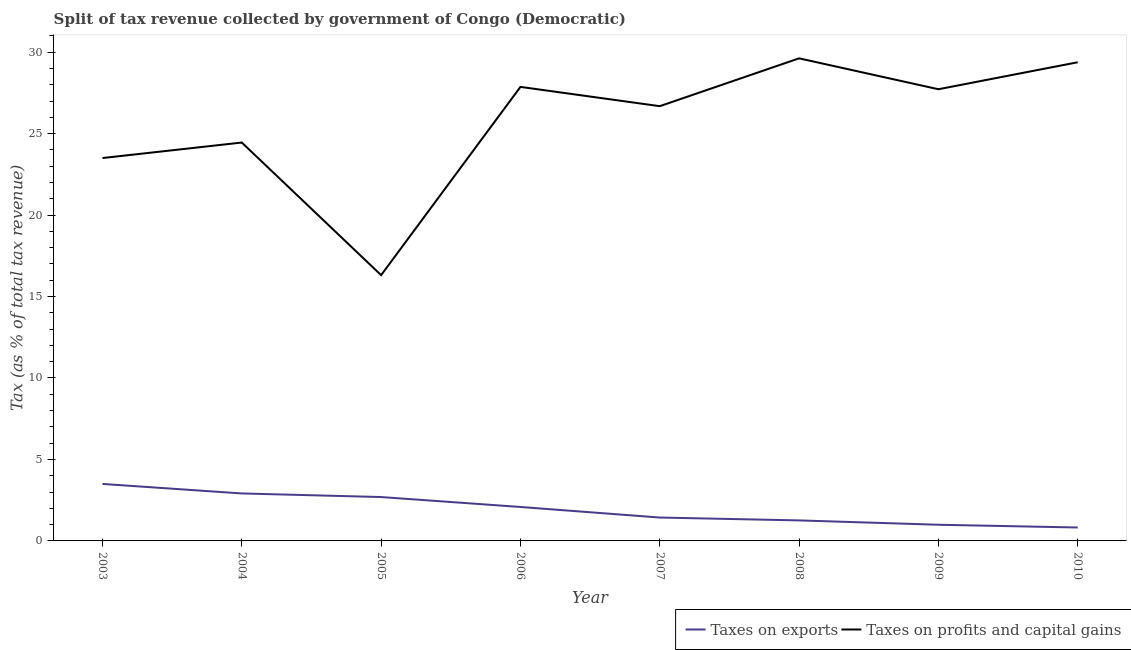Does the line corresponding to percentage of revenue obtained from taxes on profits and capital gains intersect with the line corresponding to percentage of revenue obtained from taxes on exports?
Offer a terse response. No. What is the percentage of revenue obtained from taxes on exports in 2004?
Provide a succinct answer. 2.91. Across all years, what is the maximum percentage of revenue obtained from taxes on exports?
Give a very brief answer. 3.5. Across all years, what is the minimum percentage of revenue obtained from taxes on exports?
Keep it short and to the point. 0.82. What is the total percentage of revenue obtained from taxes on profits and capital gains in the graph?
Provide a short and direct response. 205.54. What is the difference between the percentage of revenue obtained from taxes on profits and capital gains in 2003 and that in 2005?
Give a very brief answer. 7.19. What is the difference between the percentage of revenue obtained from taxes on profits and capital gains in 2008 and the percentage of revenue obtained from taxes on exports in 2007?
Your answer should be compact. 28.19. What is the average percentage of revenue obtained from taxes on profits and capital gains per year?
Offer a very short reply. 25.69. In the year 2005, what is the difference between the percentage of revenue obtained from taxes on exports and percentage of revenue obtained from taxes on profits and capital gains?
Your response must be concise. -13.62. What is the ratio of the percentage of revenue obtained from taxes on profits and capital gains in 2007 to that in 2009?
Ensure brevity in your answer.  0.96. Is the percentage of revenue obtained from taxes on exports in 2009 less than that in 2010?
Keep it short and to the point. No. What is the difference between the highest and the second highest percentage of revenue obtained from taxes on profits and capital gains?
Give a very brief answer. 0.24. What is the difference between the highest and the lowest percentage of revenue obtained from taxes on exports?
Offer a very short reply. 2.67. Is the sum of the percentage of revenue obtained from taxes on profits and capital gains in 2007 and 2008 greater than the maximum percentage of revenue obtained from taxes on exports across all years?
Make the answer very short. Yes. Does the graph contain grids?
Your answer should be compact. No. Where does the legend appear in the graph?
Ensure brevity in your answer.  Bottom right. How many legend labels are there?
Your response must be concise. 2. What is the title of the graph?
Provide a succinct answer. Split of tax revenue collected by government of Congo (Democratic). What is the label or title of the X-axis?
Provide a short and direct response. Year. What is the label or title of the Y-axis?
Make the answer very short. Tax (as % of total tax revenue). What is the Tax (as % of total tax revenue) in Taxes on exports in 2003?
Give a very brief answer. 3.5. What is the Tax (as % of total tax revenue) of Taxes on profits and capital gains in 2003?
Provide a short and direct response. 23.5. What is the Tax (as % of total tax revenue) in Taxes on exports in 2004?
Offer a terse response. 2.91. What is the Tax (as % of total tax revenue) of Taxes on profits and capital gains in 2004?
Your answer should be compact. 24.45. What is the Tax (as % of total tax revenue) of Taxes on exports in 2005?
Provide a succinct answer. 2.69. What is the Tax (as % of total tax revenue) of Taxes on profits and capital gains in 2005?
Your answer should be very brief. 16.31. What is the Tax (as % of total tax revenue) of Taxes on exports in 2006?
Keep it short and to the point. 2.08. What is the Tax (as % of total tax revenue) of Taxes on profits and capital gains in 2006?
Your answer should be compact. 27.87. What is the Tax (as % of total tax revenue) of Taxes on exports in 2007?
Your answer should be compact. 1.44. What is the Tax (as % of total tax revenue) of Taxes on profits and capital gains in 2007?
Offer a very short reply. 26.68. What is the Tax (as % of total tax revenue) of Taxes on exports in 2008?
Offer a very short reply. 1.26. What is the Tax (as % of total tax revenue) in Taxes on profits and capital gains in 2008?
Make the answer very short. 29.62. What is the Tax (as % of total tax revenue) of Taxes on exports in 2009?
Your response must be concise. 0.99. What is the Tax (as % of total tax revenue) in Taxes on profits and capital gains in 2009?
Give a very brief answer. 27.72. What is the Tax (as % of total tax revenue) of Taxes on exports in 2010?
Offer a very short reply. 0.82. What is the Tax (as % of total tax revenue) of Taxes on profits and capital gains in 2010?
Your answer should be compact. 29.38. Across all years, what is the maximum Tax (as % of total tax revenue) in Taxes on exports?
Give a very brief answer. 3.5. Across all years, what is the maximum Tax (as % of total tax revenue) in Taxes on profits and capital gains?
Offer a terse response. 29.62. Across all years, what is the minimum Tax (as % of total tax revenue) of Taxes on exports?
Give a very brief answer. 0.82. Across all years, what is the minimum Tax (as % of total tax revenue) of Taxes on profits and capital gains?
Your answer should be compact. 16.31. What is the total Tax (as % of total tax revenue) of Taxes on exports in the graph?
Keep it short and to the point. 15.7. What is the total Tax (as % of total tax revenue) of Taxes on profits and capital gains in the graph?
Give a very brief answer. 205.54. What is the difference between the Tax (as % of total tax revenue) in Taxes on exports in 2003 and that in 2004?
Make the answer very short. 0.58. What is the difference between the Tax (as % of total tax revenue) in Taxes on profits and capital gains in 2003 and that in 2004?
Offer a terse response. -0.95. What is the difference between the Tax (as % of total tax revenue) in Taxes on exports in 2003 and that in 2005?
Your response must be concise. 0.8. What is the difference between the Tax (as % of total tax revenue) in Taxes on profits and capital gains in 2003 and that in 2005?
Ensure brevity in your answer.  7.19. What is the difference between the Tax (as % of total tax revenue) in Taxes on exports in 2003 and that in 2006?
Provide a short and direct response. 1.41. What is the difference between the Tax (as % of total tax revenue) of Taxes on profits and capital gains in 2003 and that in 2006?
Give a very brief answer. -4.37. What is the difference between the Tax (as % of total tax revenue) in Taxes on exports in 2003 and that in 2007?
Make the answer very short. 2.06. What is the difference between the Tax (as % of total tax revenue) of Taxes on profits and capital gains in 2003 and that in 2007?
Provide a succinct answer. -3.18. What is the difference between the Tax (as % of total tax revenue) in Taxes on exports in 2003 and that in 2008?
Your answer should be very brief. 2.24. What is the difference between the Tax (as % of total tax revenue) of Taxes on profits and capital gains in 2003 and that in 2008?
Your answer should be compact. -6.12. What is the difference between the Tax (as % of total tax revenue) of Taxes on exports in 2003 and that in 2009?
Offer a terse response. 2.5. What is the difference between the Tax (as % of total tax revenue) of Taxes on profits and capital gains in 2003 and that in 2009?
Provide a short and direct response. -4.22. What is the difference between the Tax (as % of total tax revenue) in Taxes on exports in 2003 and that in 2010?
Keep it short and to the point. 2.67. What is the difference between the Tax (as % of total tax revenue) in Taxes on profits and capital gains in 2003 and that in 2010?
Give a very brief answer. -5.88. What is the difference between the Tax (as % of total tax revenue) in Taxes on exports in 2004 and that in 2005?
Give a very brief answer. 0.22. What is the difference between the Tax (as % of total tax revenue) in Taxes on profits and capital gains in 2004 and that in 2005?
Make the answer very short. 8.14. What is the difference between the Tax (as % of total tax revenue) of Taxes on exports in 2004 and that in 2006?
Your answer should be very brief. 0.83. What is the difference between the Tax (as % of total tax revenue) in Taxes on profits and capital gains in 2004 and that in 2006?
Your response must be concise. -3.42. What is the difference between the Tax (as % of total tax revenue) in Taxes on exports in 2004 and that in 2007?
Offer a terse response. 1.48. What is the difference between the Tax (as % of total tax revenue) in Taxes on profits and capital gains in 2004 and that in 2007?
Ensure brevity in your answer.  -2.23. What is the difference between the Tax (as % of total tax revenue) in Taxes on exports in 2004 and that in 2008?
Ensure brevity in your answer.  1.65. What is the difference between the Tax (as % of total tax revenue) of Taxes on profits and capital gains in 2004 and that in 2008?
Your answer should be very brief. -5.17. What is the difference between the Tax (as % of total tax revenue) of Taxes on exports in 2004 and that in 2009?
Ensure brevity in your answer.  1.92. What is the difference between the Tax (as % of total tax revenue) in Taxes on profits and capital gains in 2004 and that in 2009?
Provide a succinct answer. -3.27. What is the difference between the Tax (as % of total tax revenue) in Taxes on exports in 2004 and that in 2010?
Keep it short and to the point. 2.09. What is the difference between the Tax (as % of total tax revenue) of Taxes on profits and capital gains in 2004 and that in 2010?
Give a very brief answer. -4.93. What is the difference between the Tax (as % of total tax revenue) of Taxes on exports in 2005 and that in 2006?
Give a very brief answer. 0.61. What is the difference between the Tax (as % of total tax revenue) of Taxes on profits and capital gains in 2005 and that in 2006?
Ensure brevity in your answer.  -11.55. What is the difference between the Tax (as % of total tax revenue) of Taxes on exports in 2005 and that in 2007?
Provide a short and direct response. 1.26. What is the difference between the Tax (as % of total tax revenue) in Taxes on profits and capital gains in 2005 and that in 2007?
Ensure brevity in your answer.  -10.37. What is the difference between the Tax (as % of total tax revenue) in Taxes on exports in 2005 and that in 2008?
Offer a terse response. 1.43. What is the difference between the Tax (as % of total tax revenue) of Taxes on profits and capital gains in 2005 and that in 2008?
Offer a very short reply. -13.31. What is the difference between the Tax (as % of total tax revenue) in Taxes on exports in 2005 and that in 2009?
Your response must be concise. 1.7. What is the difference between the Tax (as % of total tax revenue) of Taxes on profits and capital gains in 2005 and that in 2009?
Offer a terse response. -11.41. What is the difference between the Tax (as % of total tax revenue) of Taxes on exports in 2005 and that in 2010?
Your answer should be very brief. 1.87. What is the difference between the Tax (as % of total tax revenue) of Taxes on profits and capital gains in 2005 and that in 2010?
Your answer should be very brief. -13.07. What is the difference between the Tax (as % of total tax revenue) of Taxes on exports in 2006 and that in 2007?
Make the answer very short. 0.65. What is the difference between the Tax (as % of total tax revenue) of Taxes on profits and capital gains in 2006 and that in 2007?
Keep it short and to the point. 1.18. What is the difference between the Tax (as % of total tax revenue) of Taxes on exports in 2006 and that in 2008?
Ensure brevity in your answer.  0.82. What is the difference between the Tax (as % of total tax revenue) of Taxes on profits and capital gains in 2006 and that in 2008?
Offer a very short reply. -1.75. What is the difference between the Tax (as % of total tax revenue) of Taxes on exports in 2006 and that in 2009?
Ensure brevity in your answer.  1.09. What is the difference between the Tax (as % of total tax revenue) of Taxes on profits and capital gains in 2006 and that in 2009?
Provide a succinct answer. 0.14. What is the difference between the Tax (as % of total tax revenue) of Taxes on exports in 2006 and that in 2010?
Offer a terse response. 1.26. What is the difference between the Tax (as % of total tax revenue) of Taxes on profits and capital gains in 2006 and that in 2010?
Your answer should be very brief. -1.51. What is the difference between the Tax (as % of total tax revenue) of Taxes on exports in 2007 and that in 2008?
Your answer should be very brief. 0.18. What is the difference between the Tax (as % of total tax revenue) of Taxes on profits and capital gains in 2007 and that in 2008?
Offer a very short reply. -2.94. What is the difference between the Tax (as % of total tax revenue) in Taxes on exports in 2007 and that in 2009?
Your answer should be very brief. 0.44. What is the difference between the Tax (as % of total tax revenue) of Taxes on profits and capital gains in 2007 and that in 2009?
Ensure brevity in your answer.  -1.04. What is the difference between the Tax (as % of total tax revenue) of Taxes on exports in 2007 and that in 2010?
Offer a very short reply. 0.61. What is the difference between the Tax (as % of total tax revenue) in Taxes on profits and capital gains in 2007 and that in 2010?
Provide a short and direct response. -2.7. What is the difference between the Tax (as % of total tax revenue) in Taxes on exports in 2008 and that in 2009?
Your answer should be compact. 0.27. What is the difference between the Tax (as % of total tax revenue) in Taxes on profits and capital gains in 2008 and that in 2009?
Your answer should be compact. 1.9. What is the difference between the Tax (as % of total tax revenue) in Taxes on exports in 2008 and that in 2010?
Your response must be concise. 0.44. What is the difference between the Tax (as % of total tax revenue) in Taxes on profits and capital gains in 2008 and that in 2010?
Give a very brief answer. 0.24. What is the difference between the Tax (as % of total tax revenue) of Taxes on exports in 2009 and that in 2010?
Keep it short and to the point. 0.17. What is the difference between the Tax (as % of total tax revenue) of Taxes on profits and capital gains in 2009 and that in 2010?
Give a very brief answer. -1.66. What is the difference between the Tax (as % of total tax revenue) in Taxes on exports in 2003 and the Tax (as % of total tax revenue) in Taxes on profits and capital gains in 2004?
Ensure brevity in your answer.  -20.95. What is the difference between the Tax (as % of total tax revenue) of Taxes on exports in 2003 and the Tax (as % of total tax revenue) of Taxes on profits and capital gains in 2005?
Offer a terse response. -12.82. What is the difference between the Tax (as % of total tax revenue) in Taxes on exports in 2003 and the Tax (as % of total tax revenue) in Taxes on profits and capital gains in 2006?
Give a very brief answer. -24.37. What is the difference between the Tax (as % of total tax revenue) in Taxes on exports in 2003 and the Tax (as % of total tax revenue) in Taxes on profits and capital gains in 2007?
Your answer should be compact. -23.19. What is the difference between the Tax (as % of total tax revenue) in Taxes on exports in 2003 and the Tax (as % of total tax revenue) in Taxes on profits and capital gains in 2008?
Offer a terse response. -26.12. What is the difference between the Tax (as % of total tax revenue) in Taxes on exports in 2003 and the Tax (as % of total tax revenue) in Taxes on profits and capital gains in 2009?
Keep it short and to the point. -24.23. What is the difference between the Tax (as % of total tax revenue) in Taxes on exports in 2003 and the Tax (as % of total tax revenue) in Taxes on profits and capital gains in 2010?
Provide a short and direct response. -25.88. What is the difference between the Tax (as % of total tax revenue) in Taxes on exports in 2004 and the Tax (as % of total tax revenue) in Taxes on profits and capital gains in 2005?
Your answer should be compact. -13.4. What is the difference between the Tax (as % of total tax revenue) in Taxes on exports in 2004 and the Tax (as % of total tax revenue) in Taxes on profits and capital gains in 2006?
Give a very brief answer. -24.95. What is the difference between the Tax (as % of total tax revenue) of Taxes on exports in 2004 and the Tax (as % of total tax revenue) of Taxes on profits and capital gains in 2007?
Keep it short and to the point. -23.77. What is the difference between the Tax (as % of total tax revenue) of Taxes on exports in 2004 and the Tax (as % of total tax revenue) of Taxes on profits and capital gains in 2008?
Provide a succinct answer. -26.71. What is the difference between the Tax (as % of total tax revenue) in Taxes on exports in 2004 and the Tax (as % of total tax revenue) in Taxes on profits and capital gains in 2009?
Provide a succinct answer. -24.81. What is the difference between the Tax (as % of total tax revenue) in Taxes on exports in 2004 and the Tax (as % of total tax revenue) in Taxes on profits and capital gains in 2010?
Offer a terse response. -26.47. What is the difference between the Tax (as % of total tax revenue) in Taxes on exports in 2005 and the Tax (as % of total tax revenue) in Taxes on profits and capital gains in 2006?
Your response must be concise. -25.17. What is the difference between the Tax (as % of total tax revenue) in Taxes on exports in 2005 and the Tax (as % of total tax revenue) in Taxes on profits and capital gains in 2007?
Your response must be concise. -23.99. What is the difference between the Tax (as % of total tax revenue) in Taxes on exports in 2005 and the Tax (as % of total tax revenue) in Taxes on profits and capital gains in 2008?
Your response must be concise. -26.93. What is the difference between the Tax (as % of total tax revenue) in Taxes on exports in 2005 and the Tax (as % of total tax revenue) in Taxes on profits and capital gains in 2009?
Your response must be concise. -25.03. What is the difference between the Tax (as % of total tax revenue) of Taxes on exports in 2005 and the Tax (as % of total tax revenue) of Taxes on profits and capital gains in 2010?
Provide a succinct answer. -26.69. What is the difference between the Tax (as % of total tax revenue) in Taxes on exports in 2006 and the Tax (as % of total tax revenue) in Taxes on profits and capital gains in 2007?
Your answer should be compact. -24.6. What is the difference between the Tax (as % of total tax revenue) in Taxes on exports in 2006 and the Tax (as % of total tax revenue) in Taxes on profits and capital gains in 2008?
Keep it short and to the point. -27.54. What is the difference between the Tax (as % of total tax revenue) in Taxes on exports in 2006 and the Tax (as % of total tax revenue) in Taxes on profits and capital gains in 2009?
Give a very brief answer. -25.64. What is the difference between the Tax (as % of total tax revenue) of Taxes on exports in 2006 and the Tax (as % of total tax revenue) of Taxes on profits and capital gains in 2010?
Your answer should be compact. -27.3. What is the difference between the Tax (as % of total tax revenue) in Taxes on exports in 2007 and the Tax (as % of total tax revenue) in Taxes on profits and capital gains in 2008?
Your answer should be compact. -28.19. What is the difference between the Tax (as % of total tax revenue) in Taxes on exports in 2007 and the Tax (as % of total tax revenue) in Taxes on profits and capital gains in 2009?
Offer a very short reply. -26.29. What is the difference between the Tax (as % of total tax revenue) in Taxes on exports in 2007 and the Tax (as % of total tax revenue) in Taxes on profits and capital gains in 2010?
Keep it short and to the point. -27.94. What is the difference between the Tax (as % of total tax revenue) of Taxes on exports in 2008 and the Tax (as % of total tax revenue) of Taxes on profits and capital gains in 2009?
Provide a succinct answer. -26.46. What is the difference between the Tax (as % of total tax revenue) in Taxes on exports in 2008 and the Tax (as % of total tax revenue) in Taxes on profits and capital gains in 2010?
Your response must be concise. -28.12. What is the difference between the Tax (as % of total tax revenue) in Taxes on exports in 2009 and the Tax (as % of total tax revenue) in Taxes on profits and capital gains in 2010?
Provide a succinct answer. -28.39. What is the average Tax (as % of total tax revenue) of Taxes on exports per year?
Give a very brief answer. 1.96. What is the average Tax (as % of total tax revenue) in Taxes on profits and capital gains per year?
Offer a very short reply. 25.69. In the year 2003, what is the difference between the Tax (as % of total tax revenue) of Taxes on exports and Tax (as % of total tax revenue) of Taxes on profits and capital gains?
Ensure brevity in your answer.  -20. In the year 2004, what is the difference between the Tax (as % of total tax revenue) in Taxes on exports and Tax (as % of total tax revenue) in Taxes on profits and capital gains?
Keep it short and to the point. -21.54. In the year 2005, what is the difference between the Tax (as % of total tax revenue) of Taxes on exports and Tax (as % of total tax revenue) of Taxes on profits and capital gains?
Make the answer very short. -13.62. In the year 2006, what is the difference between the Tax (as % of total tax revenue) in Taxes on exports and Tax (as % of total tax revenue) in Taxes on profits and capital gains?
Give a very brief answer. -25.78. In the year 2007, what is the difference between the Tax (as % of total tax revenue) of Taxes on exports and Tax (as % of total tax revenue) of Taxes on profits and capital gains?
Your answer should be compact. -25.25. In the year 2008, what is the difference between the Tax (as % of total tax revenue) of Taxes on exports and Tax (as % of total tax revenue) of Taxes on profits and capital gains?
Offer a terse response. -28.36. In the year 2009, what is the difference between the Tax (as % of total tax revenue) of Taxes on exports and Tax (as % of total tax revenue) of Taxes on profits and capital gains?
Give a very brief answer. -26.73. In the year 2010, what is the difference between the Tax (as % of total tax revenue) of Taxes on exports and Tax (as % of total tax revenue) of Taxes on profits and capital gains?
Offer a very short reply. -28.56. What is the ratio of the Tax (as % of total tax revenue) of Taxes on exports in 2003 to that in 2004?
Provide a short and direct response. 1.2. What is the ratio of the Tax (as % of total tax revenue) of Taxes on profits and capital gains in 2003 to that in 2004?
Your answer should be very brief. 0.96. What is the ratio of the Tax (as % of total tax revenue) of Taxes on exports in 2003 to that in 2005?
Ensure brevity in your answer.  1.3. What is the ratio of the Tax (as % of total tax revenue) in Taxes on profits and capital gains in 2003 to that in 2005?
Your response must be concise. 1.44. What is the ratio of the Tax (as % of total tax revenue) in Taxes on exports in 2003 to that in 2006?
Your answer should be compact. 1.68. What is the ratio of the Tax (as % of total tax revenue) of Taxes on profits and capital gains in 2003 to that in 2006?
Keep it short and to the point. 0.84. What is the ratio of the Tax (as % of total tax revenue) of Taxes on exports in 2003 to that in 2007?
Ensure brevity in your answer.  2.44. What is the ratio of the Tax (as % of total tax revenue) of Taxes on profits and capital gains in 2003 to that in 2007?
Give a very brief answer. 0.88. What is the ratio of the Tax (as % of total tax revenue) in Taxes on exports in 2003 to that in 2008?
Offer a terse response. 2.78. What is the ratio of the Tax (as % of total tax revenue) in Taxes on profits and capital gains in 2003 to that in 2008?
Your answer should be very brief. 0.79. What is the ratio of the Tax (as % of total tax revenue) in Taxes on exports in 2003 to that in 2009?
Keep it short and to the point. 3.52. What is the ratio of the Tax (as % of total tax revenue) in Taxes on profits and capital gains in 2003 to that in 2009?
Keep it short and to the point. 0.85. What is the ratio of the Tax (as % of total tax revenue) of Taxes on exports in 2003 to that in 2010?
Your answer should be compact. 4.25. What is the ratio of the Tax (as % of total tax revenue) of Taxes on profits and capital gains in 2003 to that in 2010?
Make the answer very short. 0.8. What is the ratio of the Tax (as % of total tax revenue) in Taxes on exports in 2004 to that in 2005?
Offer a very short reply. 1.08. What is the ratio of the Tax (as % of total tax revenue) in Taxes on profits and capital gains in 2004 to that in 2005?
Your answer should be very brief. 1.5. What is the ratio of the Tax (as % of total tax revenue) of Taxes on exports in 2004 to that in 2006?
Ensure brevity in your answer.  1.4. What is the ratio of the Tax (as % of total tax revenue) in Taxes on profits and capital gains in 2004 to that in 2006?
Provide a short and direct response. 0.88. What is the ratio of the Tax (as % of total tax revenue) in Taxes on exports in 2004 to that in 2007?
Your answer should be very brief. 2.03. What is the ratio of the Tax (as % of total tax revenue) in Taxes on profits and capital gains in 2004 to that in 2007?
Offer a very short reply. 0.92. What is the ratio of the Tax (as % of total tax revenue) of Taxes on exports in 2004 to that in 2008?
Ensure brevity in your answer.  2.31. What is the ratio of the Tax (as % of total tax revenue) of Taxes on profits and capital gains in 2004 to that in 2008?
Give a very brief answer. 0.83. What is the ratio of the Tax (as % of total tax revenue) of Taxes on exports in 2004 to that in 2009?
Keep it short and to the point. 2.94. What is the ratio of the Tax (as % of total tax revenue) of Taxes on profits and capital gains in 2004 to that in 2009?
Your answer should be compact. 0.88. What is the ratio of the Tax (as % of total tax revenue) in Taxes on exports in 2004 to that in 2010?
Keep it short and to the point. 3.54. What is the ratio of the Tax (as % of total tax revenue) in Taxes on profits and capital gains in 2004 to that in 2010?
Your answer should be very brief. 0.83. What is the ratio of the Tax (as % of total tax revenue) in Taxes on exports in 2005 to that in 2006?
Keep it short and to the point. 1.29. What is the ratio of the Tax (as % of total tax revenue) of Taxes on profits and capital gains in 2005 to that in 2006?
Give a very brief answer. 0.59. What is the ratio of the Tax (as % of total tax revenue) of Taxes on exports in 2005 to that in 2007?
Your answer should be compact. 1.88. What is the ratio of the Tax (as % of total tax revenue) in Taxes on profits and capital gains in 2005 to that in 2007?
Offer a very short reply. 0.61. What is the ratio of the Tax (as % of total tax revenue) in Taxes on exports in 2005 to that in 2008?
Give a very brief answer. 2.14. What is the ratio of the Tax (as % of total tax revenue) in Taxes on profits and capital gains in 2005 to that in 2008?
Give a very brief answer. 0.55. What is the ratio of the Tax (as % of total tax revenue) of Taxes on exports in 2005 to that in 2009?
Provide a short and direct response. 2.71. What is the ratio of the Tax (as % of total tax revenue) in Taxes on profits and capital gains in 2005 to that in 2009?
Your response must be concise. 0.59. What is the ratio of the Tax (as % of total tax revenue) of Taxes on exports in 2005 to that in 2010?
Provide a short and direct response. 3.27. What is the ratio of the Tax (as % of total tax revenue) in Taxes on profits and capital gains in 2005 to that in 2010?
Offer a terse response. 0.56. What is the ratio of the Tax (as % of total tax revenue) in Taxes on exports in 2006 to that in 2007?
Provide a succinct answer. 1.45. What is the ratio of the Tax (as % of total tax revenue) in Taxes on profits and capital gains in 2006 to that in 2007?
Provide a short and direct response. 1.04. What is the ratio of the Tax (as % of total tax revenue) in Taxes on exports in 2006 to that in 2008?
Provide a short and direct response. 1.66. What is the ratio of the Tax (as % of total tax revenue) of Taxes on profits and capital gains in 2006 to that in 2008?
Your response must be concise. 0.94. What is the ratio of the Tax (as % of total tax revenue) of Taxes on exports in 2006 to that in 2009?
Make the answer very short. 2.1. What is the ratio of the Tax (as % of total tax revenue) in Taxes on profits and capital gains in 2006 to that in 2009?
Ensure brevity in your answer.  1.01. What is the ratio of the Tax (as % of total tax revenue) of Taxes on exports in 2006 to that in 2010?
Your answer should be compact. 2.53. What is the ratio of the Tax (as % of total tax revenue) of Taxes on profits and capital gains in 2006 to that in 2010?
Provide a succinct answer. 0.95. What is the ratio of the Tax (as % of total tax revenue) of Taxes on exports in 2007 to that in 2008?
Ensure brevity in your answer.  1.14. What is the ratio of the Tax (as % of total tax revenue) in Taxes on profits and capital gains in 2007 to that in 2008?
Offer a very short reply. 0.9. What is the ratio of the Tax (as % of total tax revenue) of Taxes on exports in 2007 to that in 2009?
Make the answer very short. 1.45. What is the ratio of the Tax (as % of total tax revenue) in Taxes on profits and capital gains in 2007 to that in 2009?
Make the answer very short. 0.96. What is the ratio of the Tax (as % of total tax revenue) in Taxes on exports in 2007 to that in 2010?
Keep it short and to the point. 1.74. What is the ratio of the Tax (as % of total tax revenue) of Taxes on profits and capital gains in 2007 to that in 2010?
Provide a succinct answer. 0.91. What is the ratio of the Tax (as % of total tax revenue) in Taxes on exports in 2008 to that in 2009?
Make the answer very short. 1.27. What is the ratio of the Tax (as % of total tax revenue) in Taxes on profits and capital gains in 2008 to that in 2009?
Offer a very short reply. 1.07. What is the ratio of the Tax (as % of total tax revenue) in Taxes on exports in 2008 to that in 2010?
Offer a very short reply. 1.53. What is the ratio of the Tax (as % of total tax revenue) in Taxes on profits and capital gains in 2008 to that in 2010?
Your answer should be compact. 1.01. What is the ratio of the Tax (as % of total tax revenue) in Taxes on exports in 2009 to that in 2010?
Keep it short and to the point. 1.21. What is the ratio of the Tax (as % of total tax revenue) of Taxes on profits and capital gains in 2009 to that in 2010?
Offer a very short reply. 0.94. What is the difference between the highest and the second highest Tax (as % of total tax revenue) in Taxes on exports?
Your response must be concise. 0.58. What is the difference between the highest and the second highest Tax (as % of total tax revenue) of Taxes on profits and capital gains?
Your answer should be very brief. 0.24. What is the difference between the highest and the lowest Tax (as % of total tax revenue) in Taxes on exports?
Make the answer very short. 2.67. What is the difference between the highest and the lowest Tax (as % of total tax revenue) of Taxes on profits and capital gains?
Your answer should be compact. 13.31. 